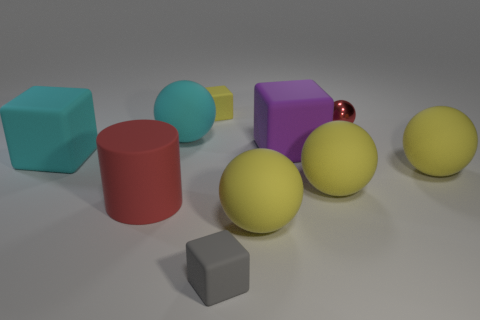Subtract all large cyan matte spheres. How many spheres are left? 4 Subtract all yellow cubes. How many yellow balls are left? 3 Subtract all yellow cubes. How many cubes are left? 3 Subtract all cubes. How many objects are left? 6 Subtract all yellow cylinders. Subtract all brown cubes. How many cylinders are left? 1 Subtract all big cyan cubes. Subtract all large cyan blocks. How many objects are left? 8 Add 2 large matte objects. How many large matte objects are left? 9 Add 9 red matte cylinders. How many red matte cylinders exist? 10 Subtract 0 cyan cylinders. How many objects are left? 10 Subtract 2 cubes. How many cubes are left? 2 